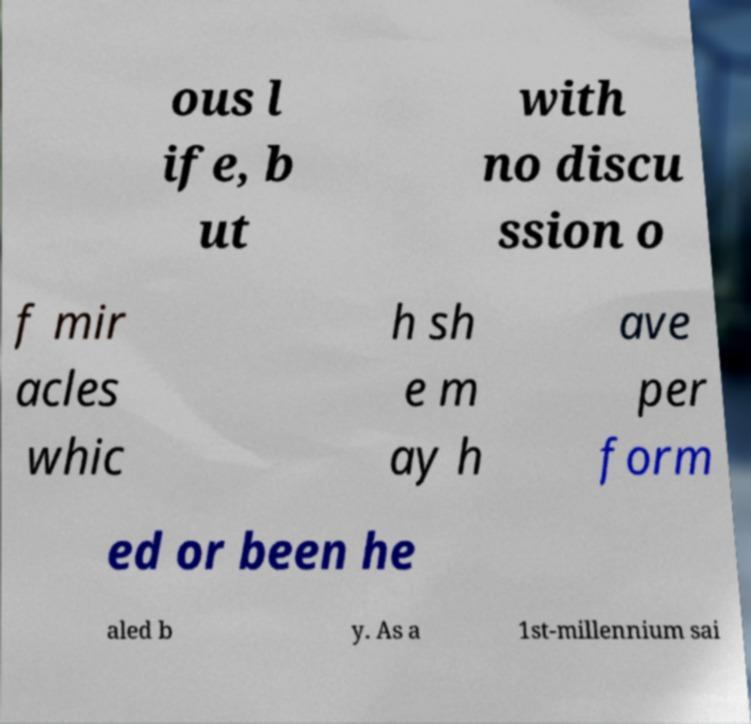What messages or text are displayed in this image? I need them in a readable, typed format. ous l ife, b ut with no discu ssion o f mir acles whic h sh e m ay h ave per form ed or been he aled b y. As a 1st-millennium sai 